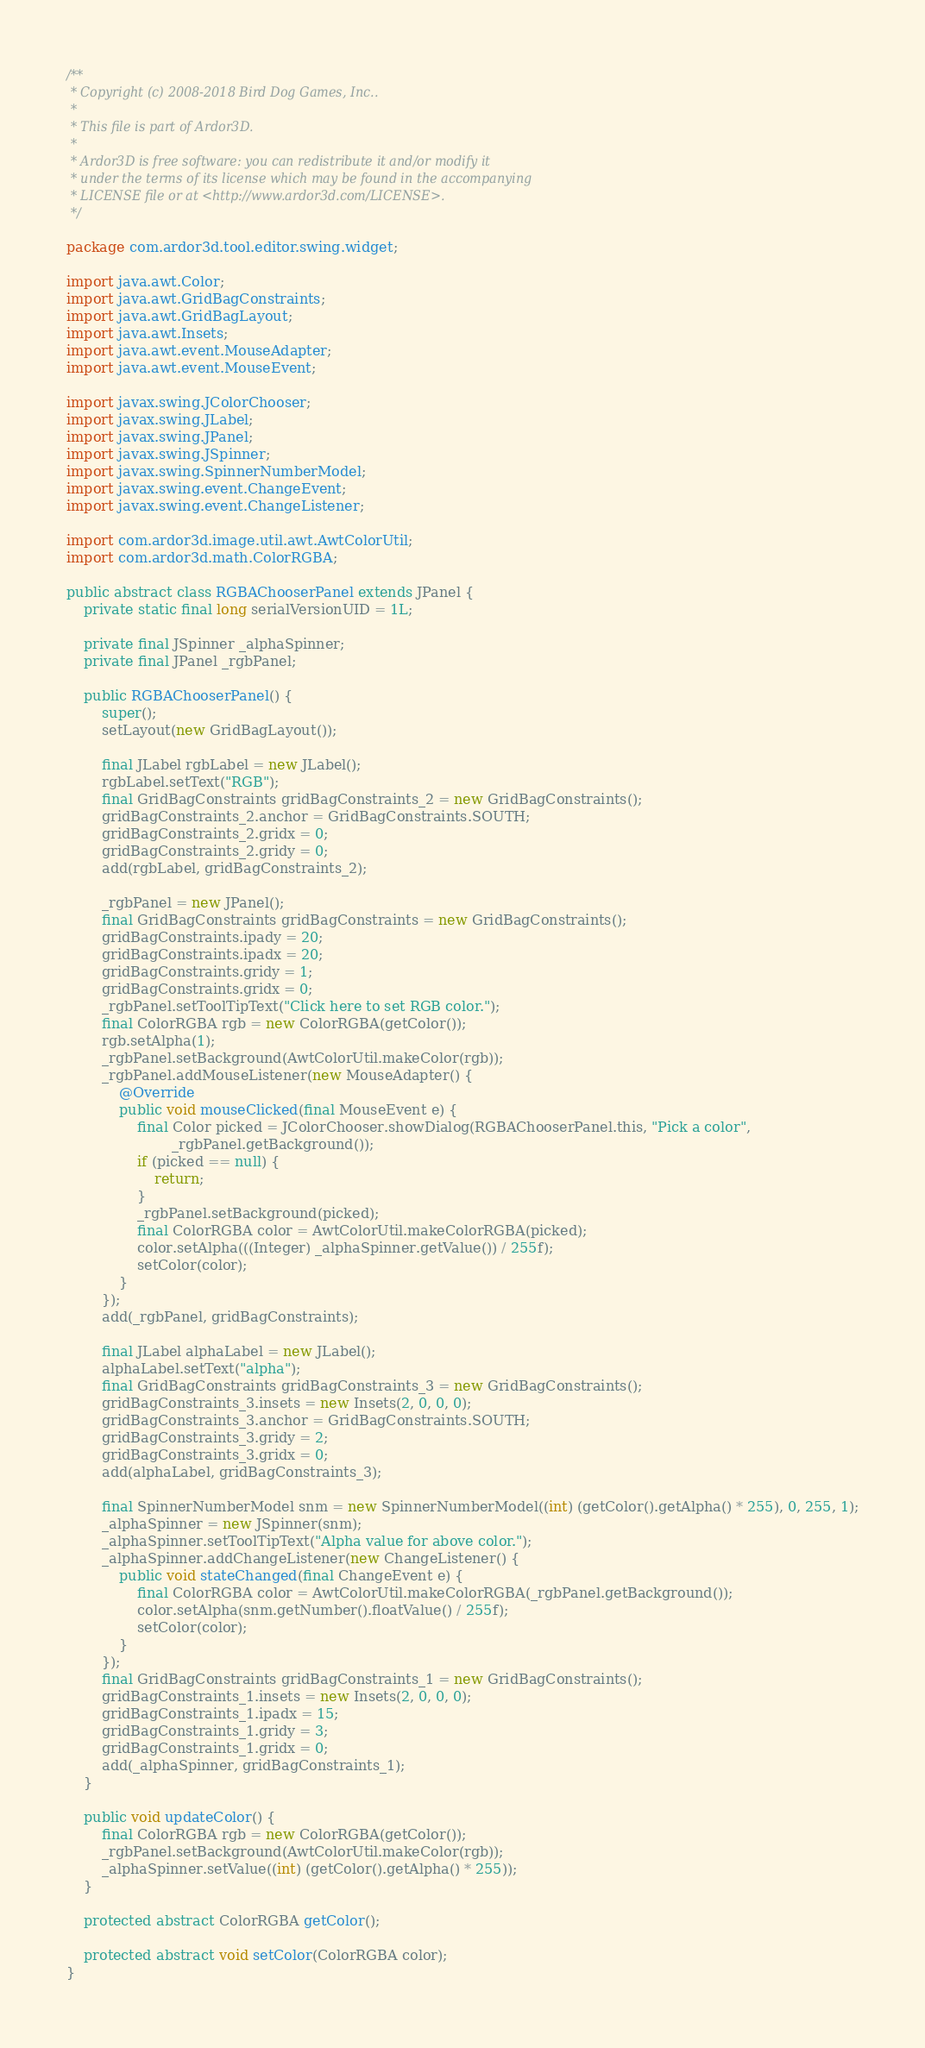Convert code to text. <code><loc_0><loc_0><loc_500><loc_500><_Java_>/**
 * Copyright (c) 2008-2018 Bird Dog Games, Inc..
 *
 * This file is part of Ardor3D.
 *
 * Ardor3D is free software: you can redistribute it and/or modify it
 * under the terms of its license which may be found in the accompanying
 * LICENSE file or at <http://www.ardor3d.com/LICENSE>.
 */

package com.ardor3d.tool.editor.swing.widget;

import java.awt.Color;
import java.awt.GridBagConstraints;
import java.awt.GridBagLayout;
import java.awt.Insets;
import java.awt.event.MouseAdapter;
import java.awt.event.MouseEvent;

import javax.swing.JColorChooser;
import javax.swing.JLabel;
import javax.swing.JPanel;
import javax.swing.JSpinner;
import javax.swing.SpinnerNumberModel;
import javax.swing.event.ChangeEvent;
import javax.swing.event.ChangeListener;

import com.ardor3d.image.util.awt.AwtColorUtil;
import com.ardor3d.math.ColorRGBA;

public abstract class RGBAChooserPanel extends JPanel {
    private static final long serialVersionUID = 1L;

    private final JSpinner _alphaSpinner;
    private final JPanel _rgbPanel;

    public RGBAChooserPanel() {
        super();
        setLayout(new GridBagLayout());

        final JLabel rgbLabel = new JLabel();
        rgbLabel.setText("RGB");
        final GridBagConstraints gridBagConstraints_2 = new GridBagConstraints();
        gridBagConstraints_2.anchor = GridBagConstraints.SOUTH;
        gridBagConstraints_2.gridx = 0;
        gridBagConstraints_2.gridy = 0;
        add(rgbLabel, gridBagConstraints_2);

        _rgbPanel = new JPanel();
        final GridBagConstraints gridBagConstraints = new GridBagConstraints();
        gridBagConstraints.ipady = 20;
        gridBagConstraints.ipadx = 20;
        gridBagConstraints.gridy = 1;
        gridBagConstraints.gridx = 0;
        _rgbPanel.setToolTipText("Click here to set RGB color.");
        final ColorRGBA rgb = new ColorRGBA(getColor());
        rgb.setAlpha(1);
        _rgbPanel.setBackground(AwtColorUtil.makeColor(rgb));
        _rgbPanel.addMouseListener(new MouseAdapter() {
            @Override
            public void mouseClicked(final MouseEvent e) {
                final Color picked = JColorChooser.showDialog(RGBAChooserPanel.this, "Pick a color",
                        _rgbPanel.getBackground());
                if (picked == null) {
                    return;
                }
                _rgbPanel.setBackground(picked);
                final ColorRGBA color = AwtColorUtil.makeColorRGBA(picked);
                color.setAlpha(((Integer) _alphaSpinner.getValue()) / 255f);
                setColor(color);
            }
        });
        add(_rgbPanel, gridBagConstraints);

        final JLabel alphaLabel = new JLabel();
        alphaLabel.setText("alpha");
        final GridBagConstraints gridBagConstraints_3 = new GridBagConstraints();
        gridBagConstraints_3.insets = new Insets(2, 0, 0, 0);
        gridBagConstraints_3.anchor = GridBagConstraints.SOUTH;
        gridBagConstraints_3.gridy = 2;
        gridBagConstraints_3.gridx = 0;
        add(alphaLabel, gridBagConstraints_3);

        final SpinnerNumberModel snm = new SpinnerNumberModel((int) (getColor().getAlpha() * 255), 0, 255, 1);
        _alphaSpinner = new JSpinner(snm);
        _alphaSpinner.setToolTipText("Alpha value for above color.");
        _alphaSpinner.addChangeListener(new ChangeListener() {
            public void stateChanged(final ChangeEvent e) {
                final ColorRGBA color = AwtColorUtil.makeColorRGBA(_rgbPanel.getBackground());
                color.setAlpha(snm.getNumber().floatValue() / 255f);
                setColor(color);
            }
        });
        final GridBagConstraints gridBagConstraints_1 = new GridBagConstraints();
        gridBagConstraints_1.insets = new Insets(2, 0, 0, 0);
        gridBagConstraints_1.ipadx = 15;
        gridBagConstraints_1.gridy = 3;
        gridBagConstraints_1.gridx = 0;
        add(_alphaSpinner, gridBagConstraints_1);
    }

    public void updateColor() {
        final ColorRGBA rgb = new ColorRGBA(getColor());
        _rgbPanel.setBackground(AwtColorUtil.makeColor(rgb));
        _alphaSpinner.setValue((int) (getColor().getAlpha() * 255));
    }

    protected abstract ColorRGBA getColor();

    protected abstract void setColor(ColorRGBA color);
}</code> 